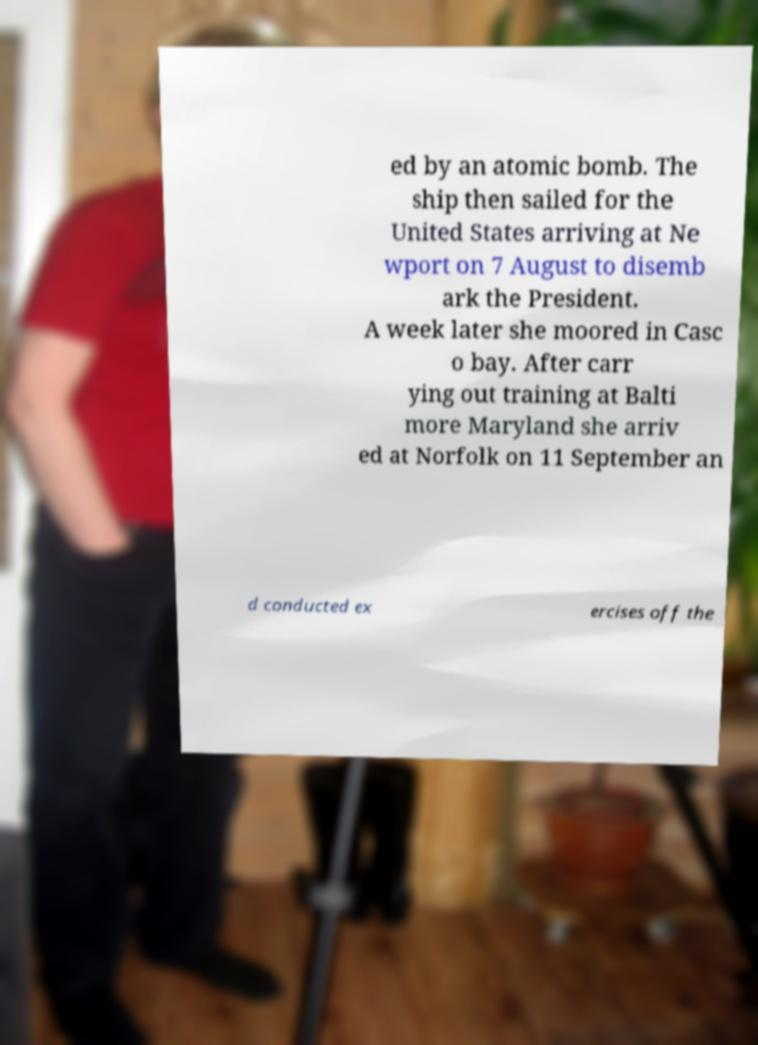For documentation purposes, I need the text within this image transcribed. Could you provide that? ed by an atomic bomb. The ship then sailed for the United States arriving at Ne wport on 7 August to disemb ark the President. A week later she moored in Casc o bay. After carr ying out training at Balti more Maryland she arriv ed at Norfolk on 11 September an d conducted ex ercises off the 